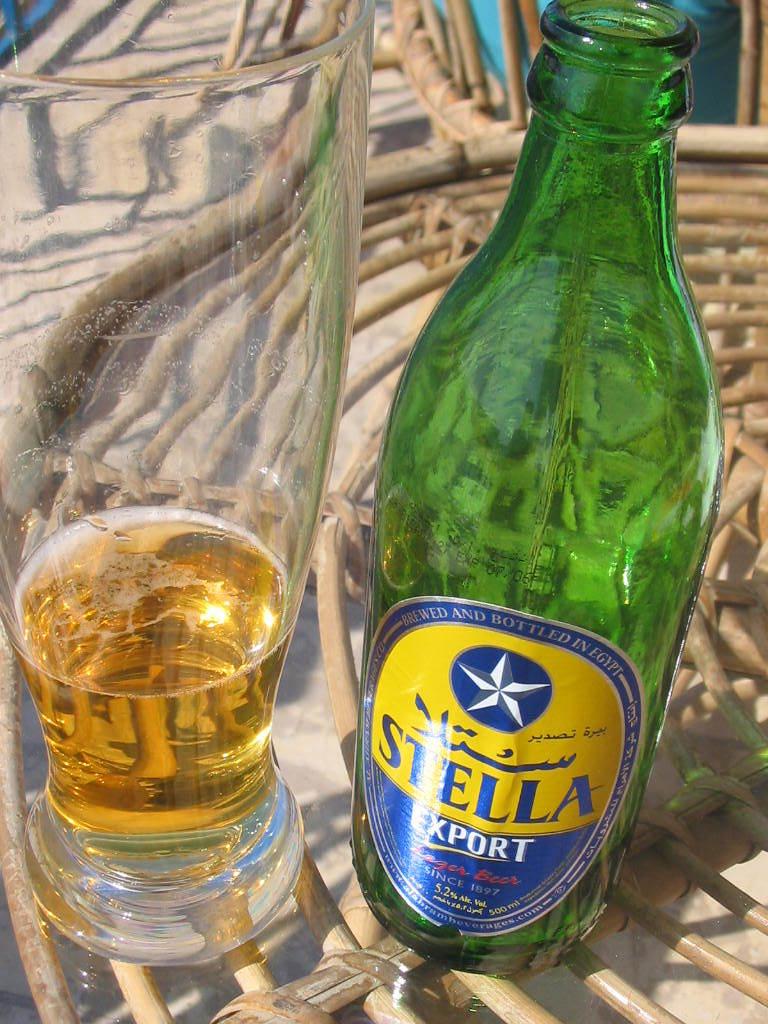What is the brand of the beer?
Give a very brief answer. Stella. What is the alcohol volume shown in this bottle?
Provide a succinct answer. 5.2%. 